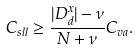<formula> <loc_0><loc_0><loc_500><loc_500>C _ { s l l } \geq \frac { | D _ { d } ^ { x } | - \nu } { N + \nu } C _ { v a } .</formula> 